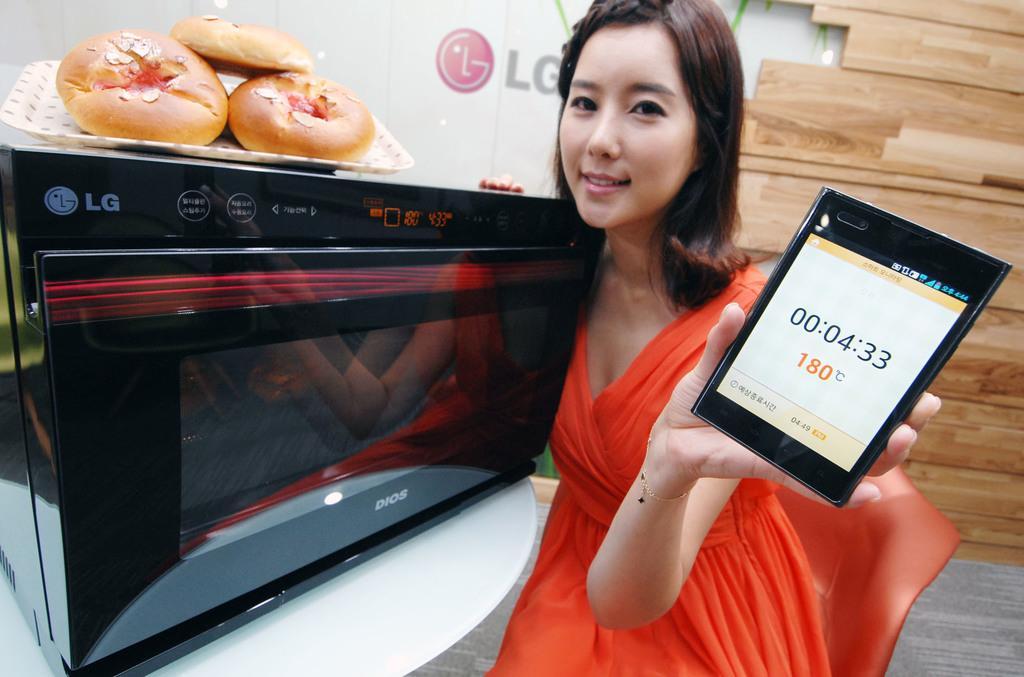Can you describe this image briefly? In this picture we can see a woman is holding a mobile phone, on the left side there is a microwave oven, we can see a tray on the oven, there is some food present in the trap, we can see LG logo in the background. 